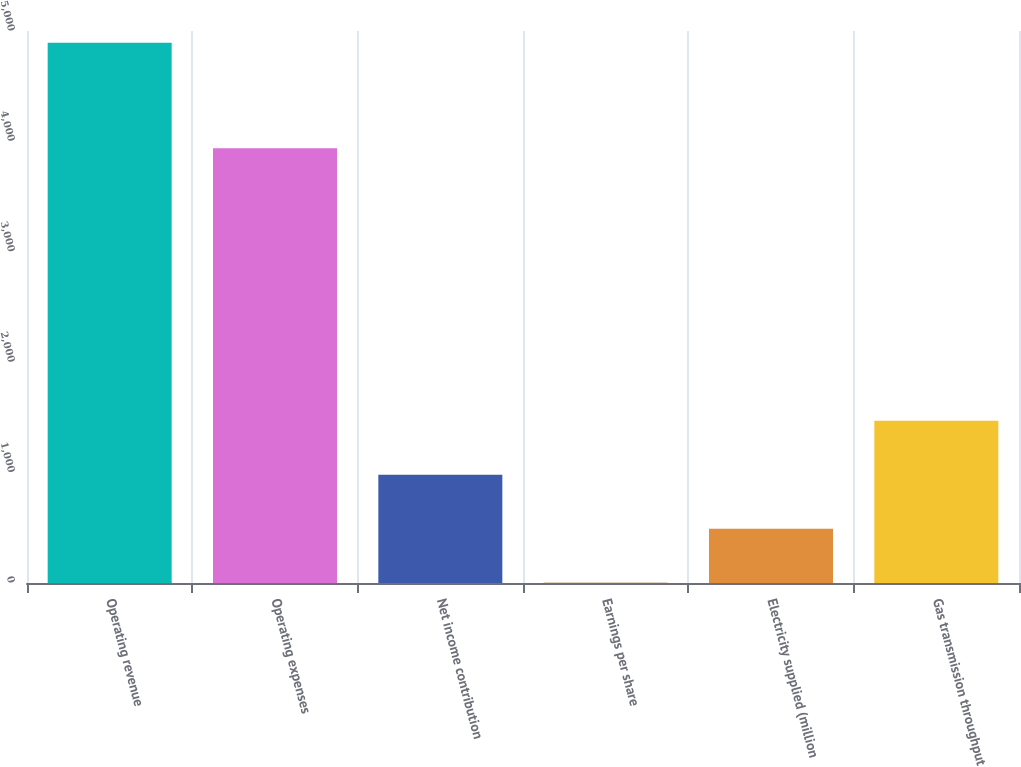Convert chart. <chart><loc_0><loc_0><loc_500><loc_500><bar_chart><fcel>Operating revenue<fcel>Operating expenses<fcel>Net income contribution<fcel>Earnings per share<fcel>Electricity supplied (million<fcel>Gas transmission throughput<nl><fcel>4894<fcel>3939<fcel>980.45<fcel>2.07<fcel>491.26<fcel>1469.64<nl></chart> 